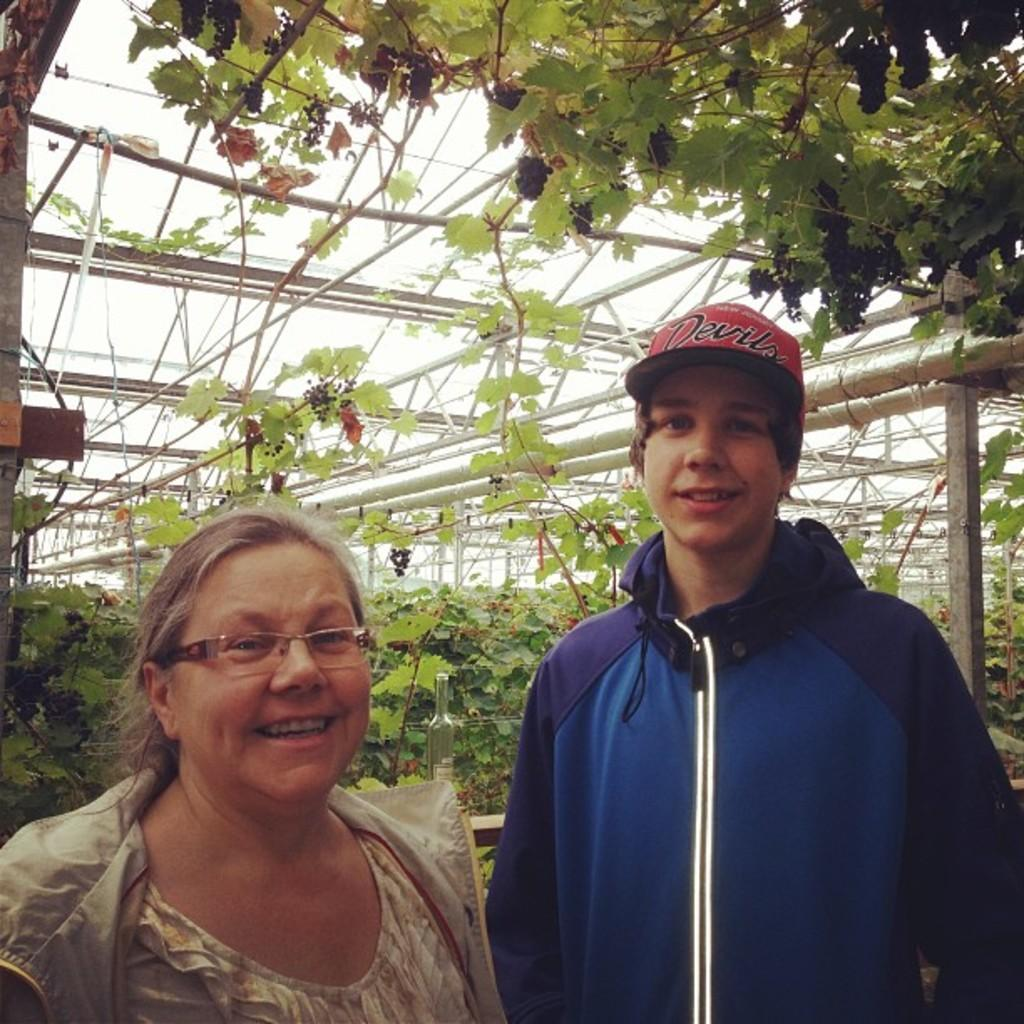Who are the people in the image? There is a boy and a woman in the image. What are the boy and woman doing in the image? The boy and woman are standing. What can be seen in the background of the image? There are plants and poles in the background of the image. What type of mask is the secretary wearing in the image? There is no secretary or mask present in the image. What type of jeans is the boy wearing in the image? The provided facts do not mention the type of clothing the boy is wearing, so it cannot be determined from the image. 